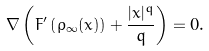<formula> <loc_0><loc_0><loc_500><loc_500>\nabla \left ( F ^ { \prime } \left ( \rho _ { \infty } ( x ) \right ) + \frac { | x | ^ { q } } { q } \right ) = 0 .</formula> 